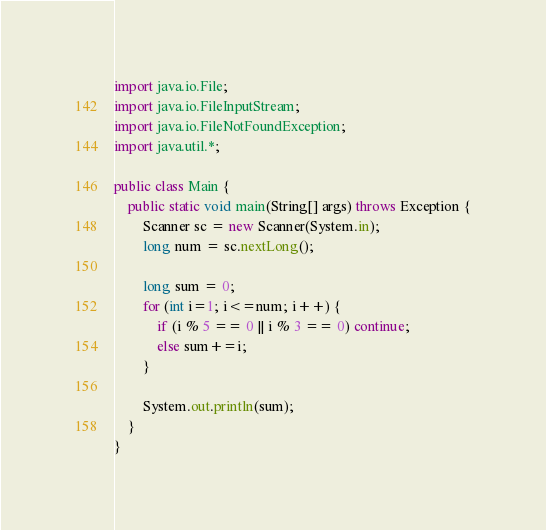Convert code to text. <code><loc_0><loc_0><loc_500><loc_500><_Java_>import java.io.File;
import java.io.FileInputStream;
import java.io.FileNotFoundException;
import java.util.*;

public class Main {
    public static void main(String[] args) throws Exception {
        Scanner sc = new Scanner(System.in);
        long num = sc.nextLong();

        long sum = 0;
        for (int i=1; i<=num; i++) {
            if (i % 5 == 0 || i % 3 == 0) continue;
            else sum+=i;
        }

        System.out.println(sum);
    }
}
</code> 